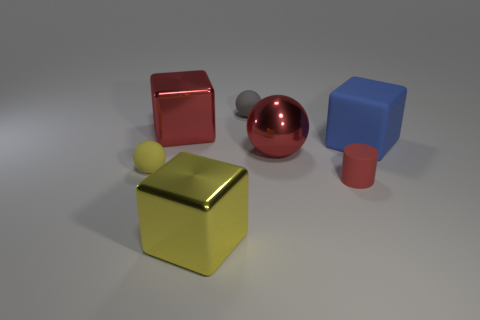Add 2 gray shiny spheres. How many objects exist? 9 Subtract all spheres. How many objects are left? 4 Add 6 large yellow metallic cubes. How many large yellow metallic cubes exist? 7 Subtract 1 gray balls. How many objects are left? 6 Subtract all tiny cyan shiny balls. Subtract all tiny gray objects. How many objects are left? 6 Add 3 small red cylinders. How many small red cylinders are left? 4 